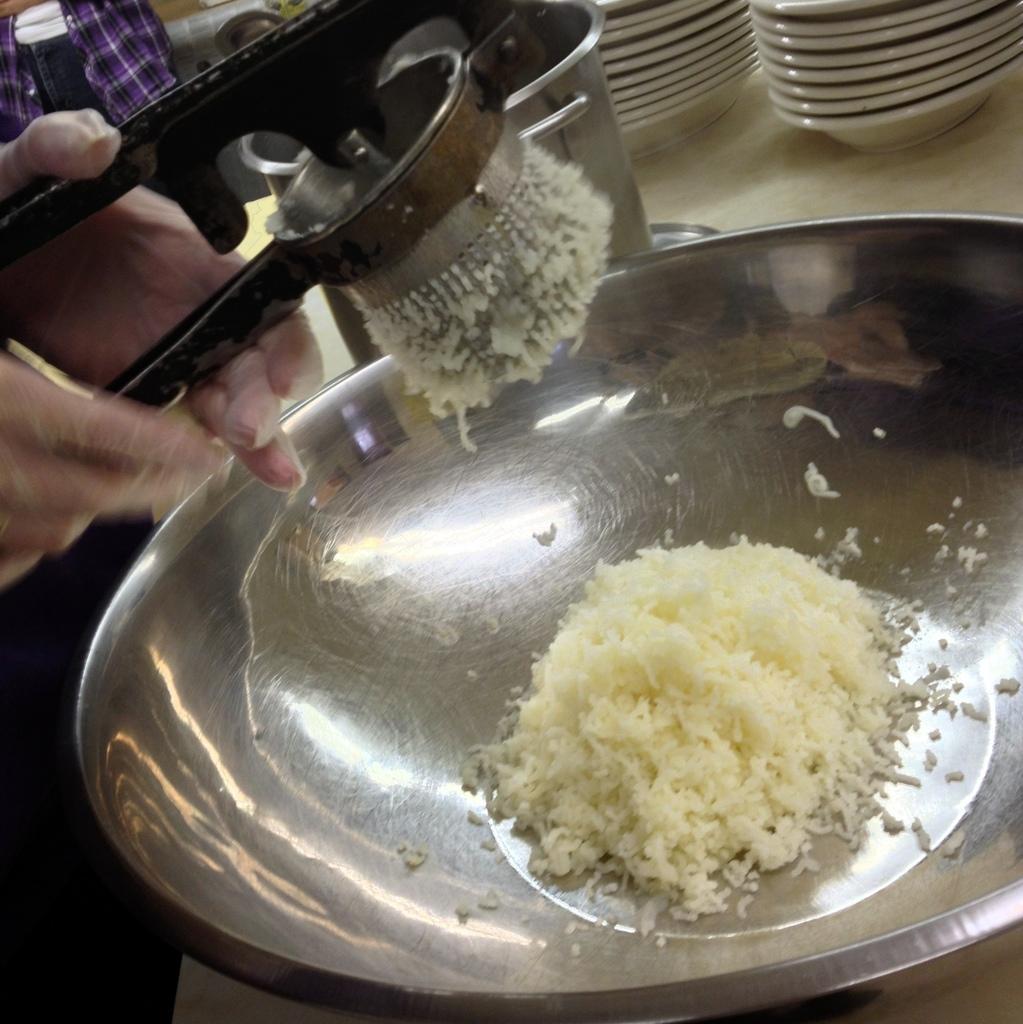How would you summarize this image in a sentence or two? In the center of the image we can see one table. On the table, we can see plates, bowls, containers and a few other objects. In the front bowl, we can see some food item. On the left side of the image we can see human hands holding some object. 